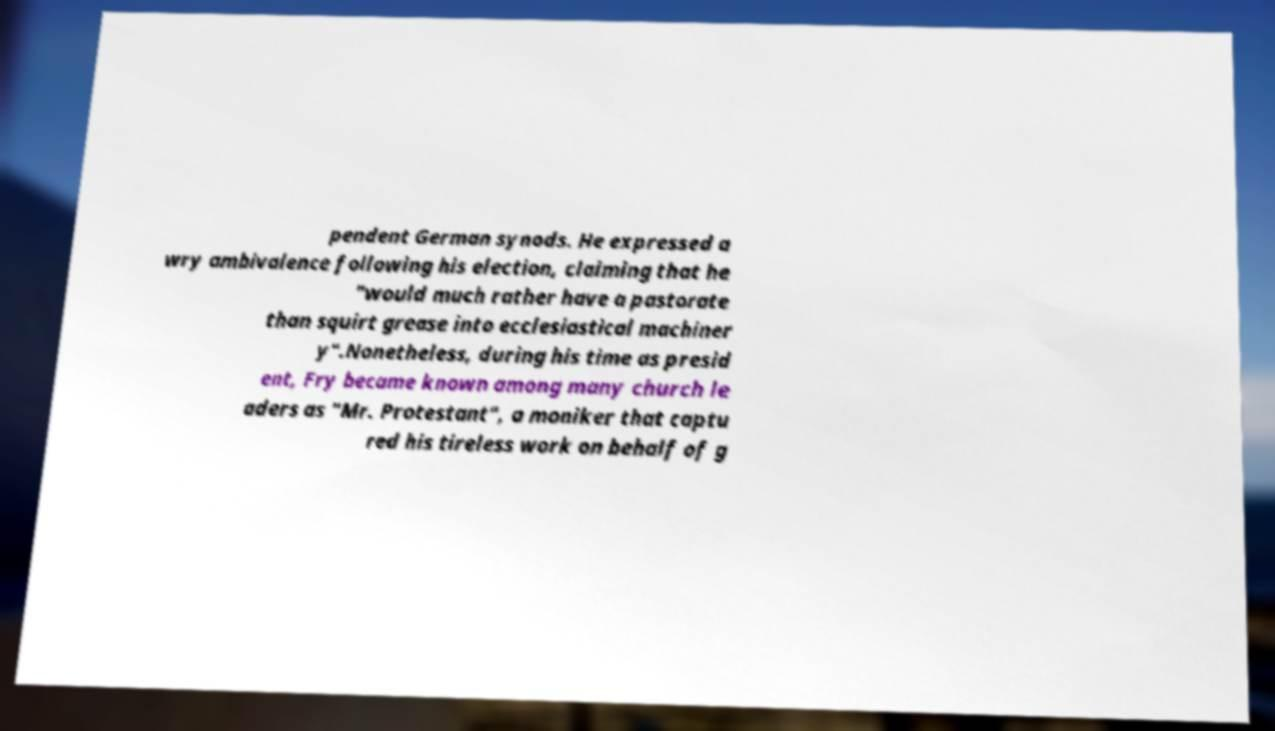Can you accurately transcribe the text from the provided image for me? pendent German synods. He expressed a wry ambivalence following his election, claiming that he "would much rather have a pastorate than squirt grease into ecclesiastical machiner y".Nonetheless, during his time as presid ent, Fry became known among many church le aders as "Mr. Protestant", a moniker that captu red his tireless work on behalf of g 